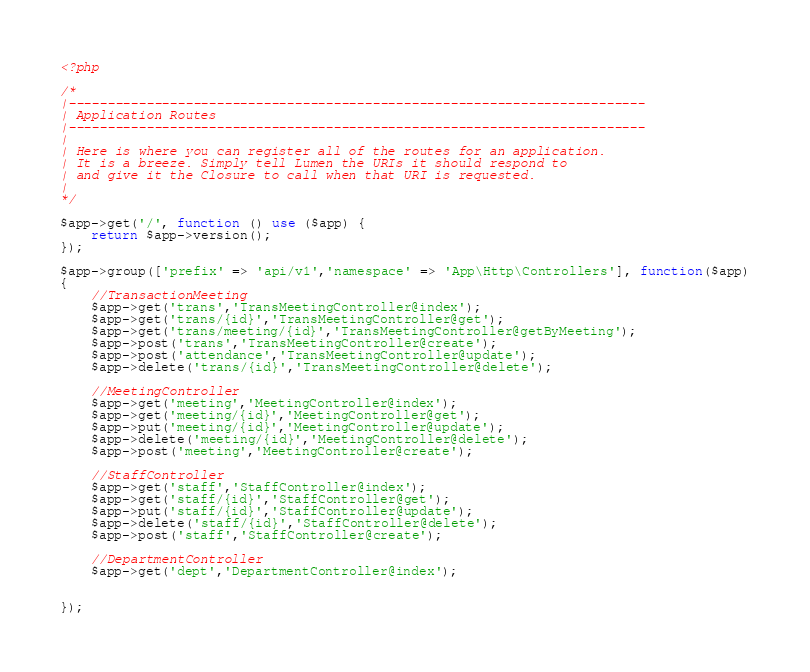Convert code to text. <code><loc_0><loc_0><loc_500><loc_500><_PHP_><?php

/*
|--------------------------------------------------------------------------
| Application Routes
|--------------------------------------------------------------------------
|
| Here is where you can register all of the routes for an application.
| It is a breeze. Simply tell Lumen the URIs it should respond to
| and give it the Closure to call when that URI is requested.
|
*/

$app->get('/', function () use ($app) {
    return $app->version();
});

$app->group(['prefix' => 'api/v1','namespace' => 'App\Http\Controllers'], function($app)
{
    //TransactionMeeting
    $app->get('trans','TransMeetingController@index');
    $app->get('trans/{id}','TransMeetingController@get');
    $app->get('trans/meeting/{id}','TransMeetingController@getByMeeting');
    $app->post('trans','TransMeetingController@create');
    $app->post('attendance','TransMeetingController@update');
    $app->delete('trans/{id}','TransMeetingController@delete');

    //MeetingController
    $app->get('meeting','MeetingController@index');
    $app->get('meeting/{id}','MeetingController@get');
    $app->put('meeting/{id}','MeetingController@update');
    $app->delete('meeting/{id}','MeetingController@delete');
    $app->post('meeting','MeetingController@create');

    //StaffController
    $app->get('staff','StaffController@index');
    $app->get('staff/{id}','StaffController@get');
    $app->put('staff/{id}','StaffController@update');
    $app->delete('staff/{id}','StaffController@delete');
    $app->post('staff','StaffController@create');

    //DepartmentController
    $app->get('dept','DepartmentController@index');


});
</code> 